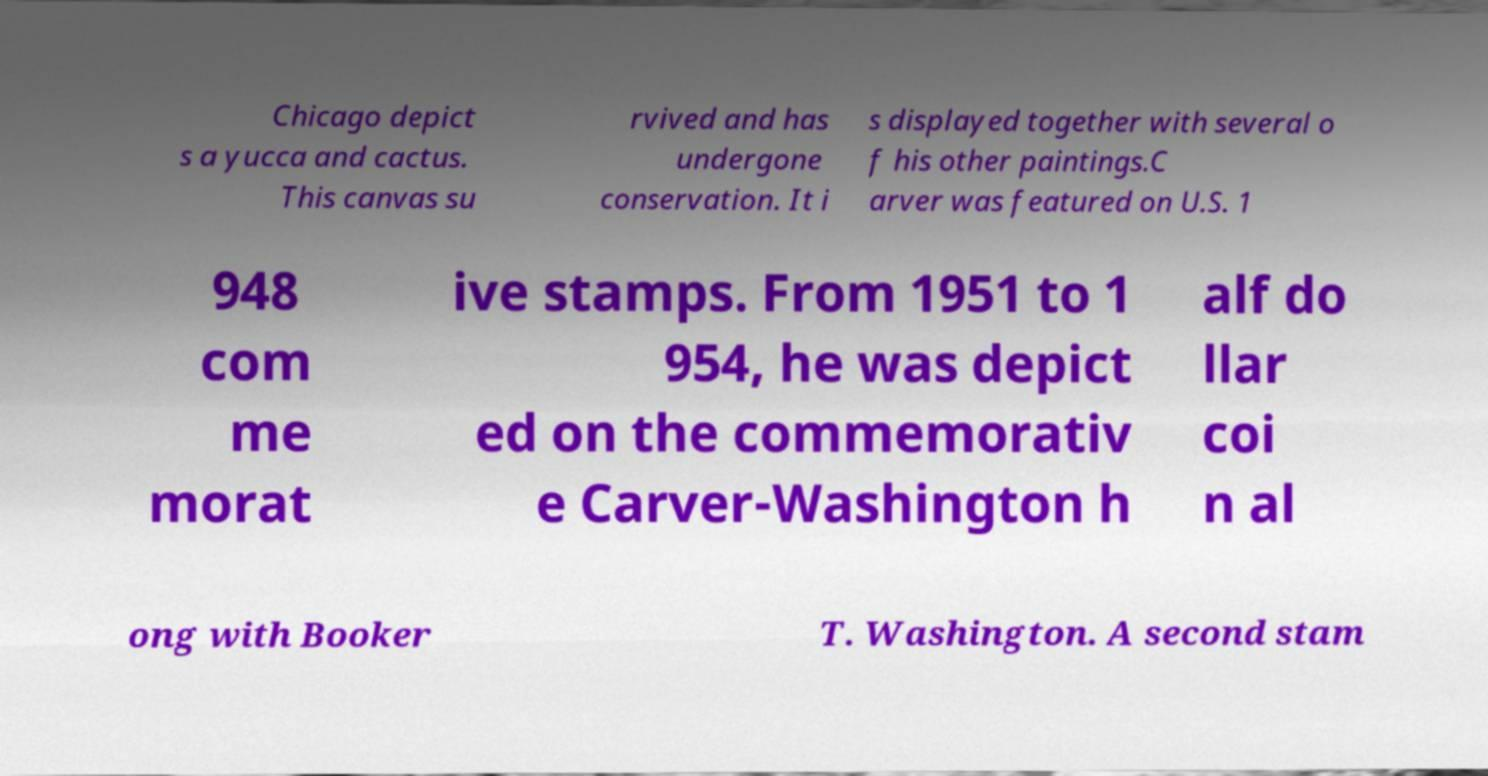Please identify and transcribe the text found in this image. Chicago depict s a yucca and cactus. This canvas su rvived and has undergone conservation. It i s displayed together with several o f his other paintings.C arver was featured on U.S. 1 948 com me morat ive stamps. From 1951 to 1 954, he was depict ed on the commemorativ e Carver-Washington h alf do llar coi n al ong with Booker T. Washington. A second stam 